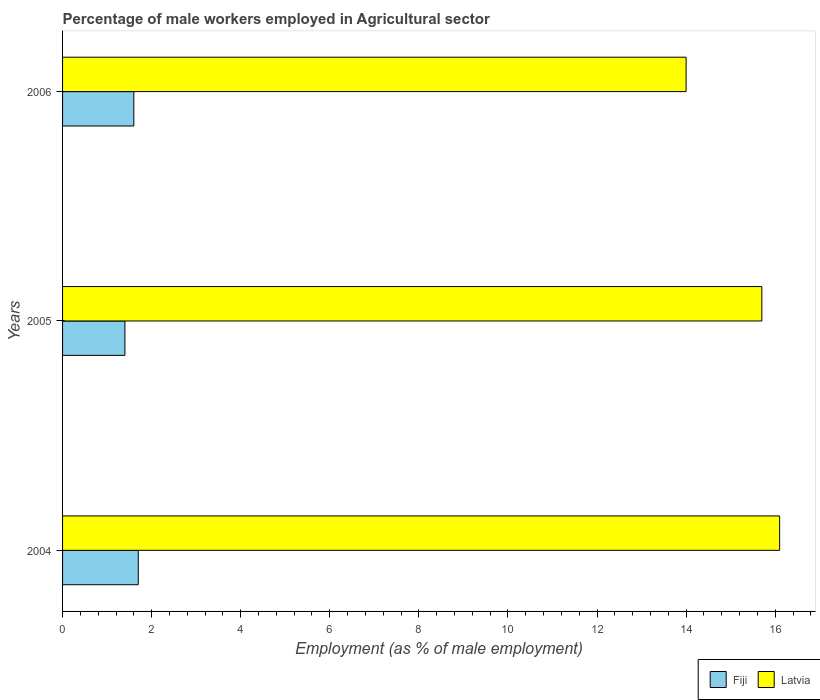How many groups of bars are there?
Give a very brief answer. 3. Are the number of bars per tick equal to the number of legend labels?
Your answer should be compact. Yes. How many bars are there on the 3rd tick from the top?
Offer a very short reply. 2. What is the percentage of male workers employed in Agricultural sector in Latvia in 2005?
Offer a very short reply. 15.7. Across all years, what is the maximum percentage of male workers employed in Agricultural sector in Latvia?
Give a very brief answer. 16.1. Across all years, what is the minimum percentage of male workers employed in Agricultural sector in Fiji?
Give a very brief answer. 1.4. In which year was the percentage of male workers employed in Agricultural sector in Latvia minimum?
Your answer should be compact. 2006. What is the total percentage of male workers employed in Agricultural sector in Latvia in the graph?
Offer a terse response. 45.8. What is the difference between the percentage of male workers employed in Agricultural sector in Latvia in 2005 and that in 2006?
Offer a very short reply. 1.7. What is the difference between the percentage of male workers employed in Agricultural sector in Latvia in 2004 and the percentage of male workers employed in Agricultural sector in Fiji in 2006?
Keep it short and to the point. 14.5. What is the average percentage of male workers employed in Agricultural sector in Fiji per year?
Ensure brevity in your answer.  1.57. In the year 2004, what is the difference between the percentage of male workers employed in Agricultural sector in Fiji and percentage of male workers employed in Agricultural sector in Latvia?
Make the answer very short. -14.4. In how many years, is the percentage of male workers employed in Agricultural sector in Fiji greater than 13.6 %?
Keep it short and to the point. 0. What is the ratio of the percentage of male workers employed in Agricultural sector in Fiji in 2004 to that in 2005?
Offer a very short reply. 1.21. Is the percentage of male workers employed in Agricultural sector in Fiji in 2004 less than that in 2005?
Provide a succinct answer. No. What is the difference between the highest and the second highest percentage of male workers employed in Agricultural sector in Fiji?
Ensure brevity in your answer.  0.1. What is the difference between the highest and the lowest percentage of male workers employed in Agricultural sector in Latvia?
Offer a very short reply. 2.1. In how many years, is the percentage of male workers employed in Agricultural sector in Fiji greater than the average percentage of male workers employed in Agricultural sector in Fiji taken over all years?
Offer a very short reply. 2. Is the sum of the percentage of male workers employed in Agricultural sector in Fiji in 2005 and 2006 greater than the maximum percentage of male workers employed in Agricultural sector in Latvia across all years?
Offer a very short reply. No. What does the 1st bar from the top in 2006 represents?
Provide a succinct answer. Latvia. What does the 2nd bar from the bottom in 2006 represents?
Your answer should be very brief. Latvia. How many bars are there?
Your response must be concise. 6. How many years are there in the graph?
Make the answer very short. 3. What is the difference between two consecutive major ticks on the X-axis?
Provide a succinct answer. 2. Does the graph contain grids?
Provide a succinct answer. No. Where does the legend appear in the graph?
Your response must be concise. Bottom right. How many legend labels are there?
Offer a very short reply. 2. How are the legend labels stacked?
Provide a short and direct response. Horizontal. What is the title of the graph?
Keep it short and to the point. Percentage of male workers employed in Agricultural sector. What is the label or title of the X-axis?
Provide a short and direct response. Employment (as % of male employment). What is the Employment (as % of male employment) in Fiji in 2004?
Your response must be concise. 1.7. What is the Employment (as % of male employment) in Latvia in 2004?
Your answer should be compact. 16.1. What is the Employment (as % of male employment) of Fiji in 2005?
Your answer should be compact. 1.4. What is the Employment (as % of male employment) of Latvia in 2005?
Your answer should be very brief. 15.7. What is the Employment (as % of male employment) of Fiji in 2006?
Make the answer very short. 1.6. What is the Employment (as % of male employment) of Latvia in 2006?
Provide a succinct answer. 14. Across all years, what is the maximum Employment (as % of male employment) in Fiji?
Provide a succinct answer. 1.7. Across all years, what is the maximum Employment (as % of male employment) in Latvia?
Make the answer very short. 16.1. Across all years, what is the minimum Employment (as % of male employment) in Fiji?
Provide a succinct answer. 1.4. What is the total Employment (as % of male employment) in Latvia in the graph?
Offer a very short reply. 45.8. What is the difference between the Employment (as % of male employment) of Latvia in 2004 and that in 2005?
Your answer should be very brief. 0.4. What is the difference between the Employment (as % of male employment) of Fiji in 2004 and that in 2006?
Offer a terse response. 0.1. What is the difference between the Employment (as % of male employment) in Latvia in 2004 and that in 2006?
Keep it short and to the point. 2.1. What is the difference between the Employment (as % of male employment) of Fiji in 2005 and that in 2006?
Provide a succinct answer. -0.2. What is the difference between the Employment (as % of male employment) in Fiji in 2004 and the Employment (as % of male employment) in Latvia in 2006?
Offer a very short reply. -12.3. What is the difference between the Employment (as % of male employment) in Fiji in 2005 and the Employment (as % of male employment) in Latvia in 2006?
Your answer should be very brief. -12.6. What is the average Employment (as % of male employment) in Fiji per year?
Your answer should be compact. 1.57. What is the average Employment (as % of male employment) of Latvia per year?
Make the answer very short. 15.27. In the year 2004, what is the difference between the Employment (as % of male employment) of Fiji and Employment (as % of male employment) of Latvia?
Your response must be concise. -14.4. In the year 2005, what is the difference between the Employment (as % of male employment) in Fiji and Employment (as % of male employment) in Latvia?
Make the answer very short. -14.3. In the year 2006, what is the difference between the Employment (as % of male employment) of Fiji and Employment (as % of male employment) of Latvia?
Provide a short and direct response. -12.4. What is the ratio of the Employment (as % of male employment) in Fiji in 2004 to that in 2005?
Provide a succinct answer. 1.21. What is the ratio of the Employment (as % of male employment) of Latvia in 2004 to that in 2005?
Offer a very short reply. 1.03. What is the ratio of the Employment (as % of male employment) in Latvia in 2004 to that in 2006?
Offer a terse response. 1.15. What is the ratio of the Employment (as % of male employment) in Latvia in 2005 to that in 2006?
Offer a terse response. 1.12. What is the difference between the highest and the second highest Employment (as % of male employment) in Fiji?
Offer a very short reply. 0.1. What is the difference between the highest and the lowest Employment (as % of male employment) in Fiji?
Provide a succinct answer. 0.3. 